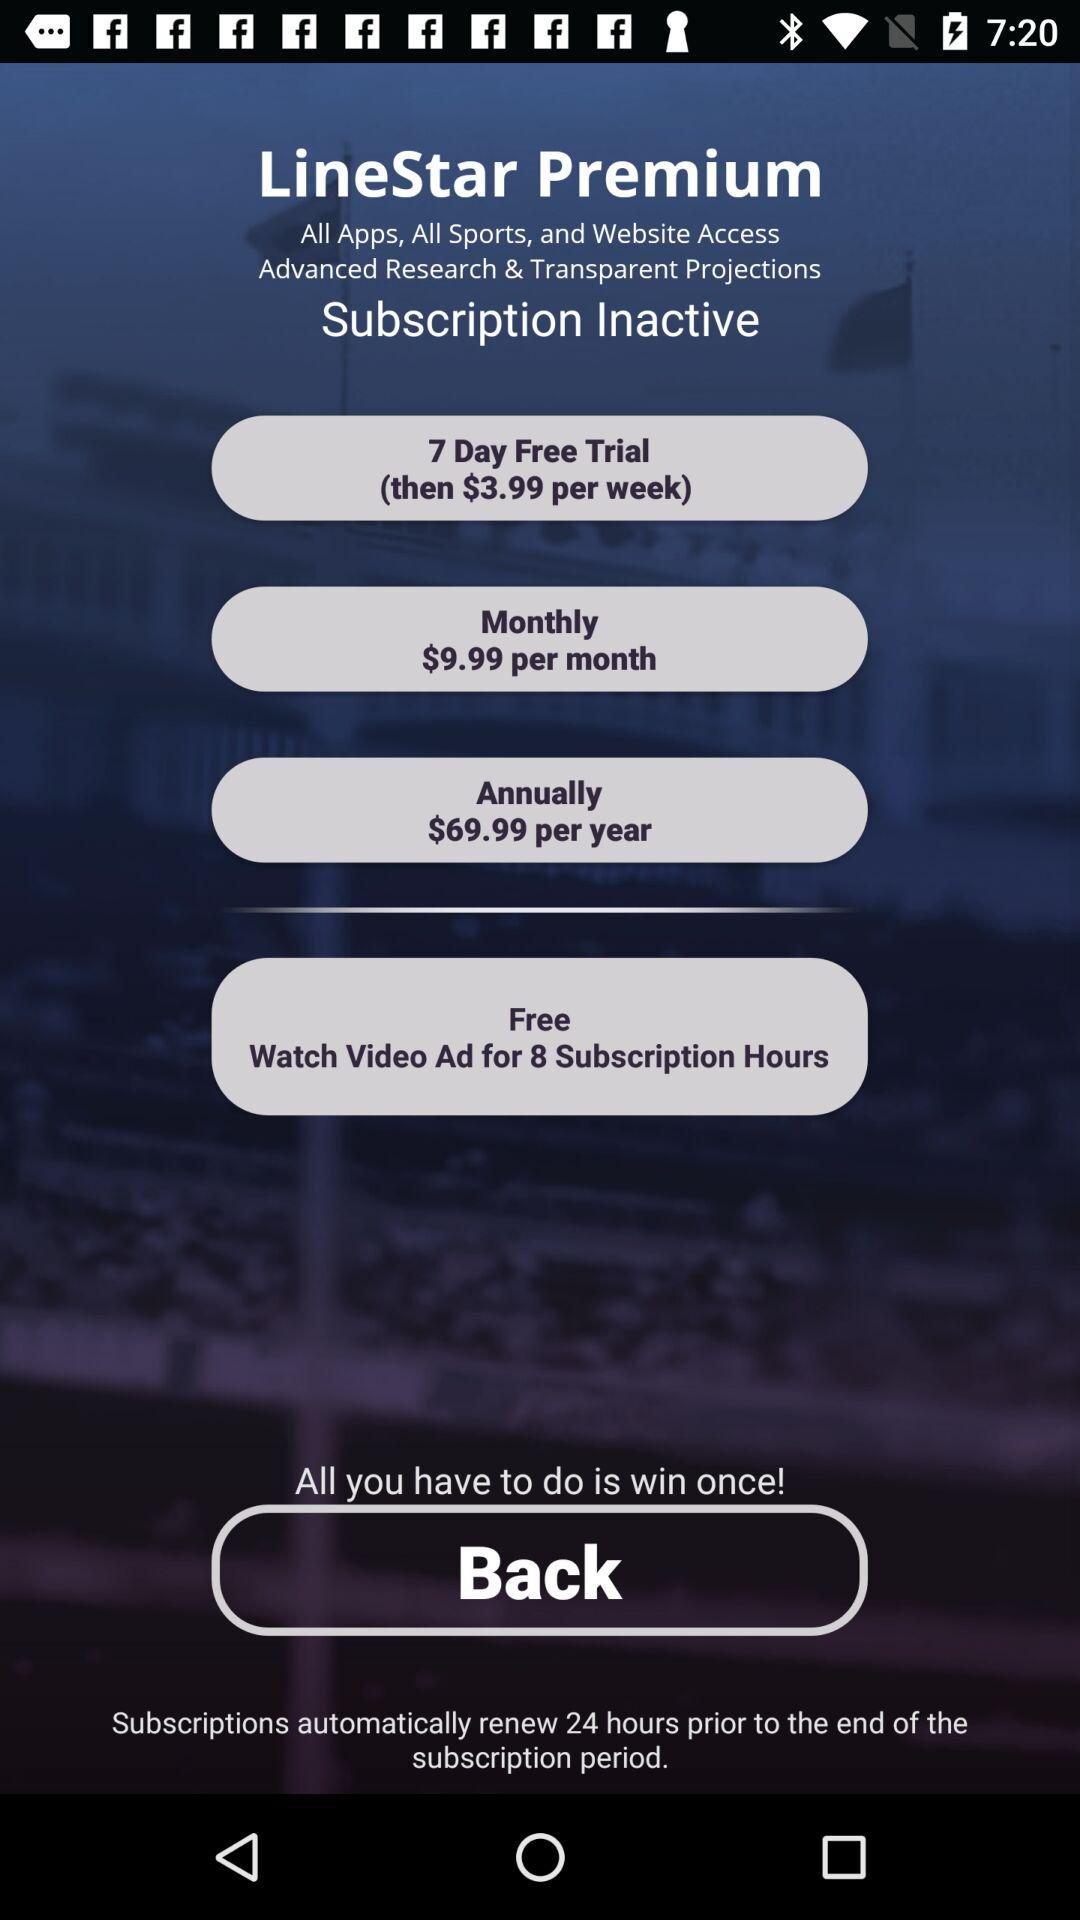How much is the price for the monthly premium? The price is $9.99. 